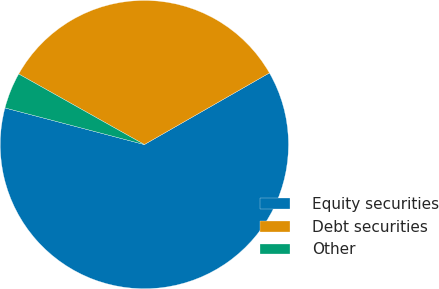<chart> <loc_0><loc_0><loc_500><loc_500><pie_chart><fcel>Equity securities<fcel>Debt securities<fcel>Other<nl><fcel>62.37%<fcel>33.58%<fcel>4.05%<nl></chart> 